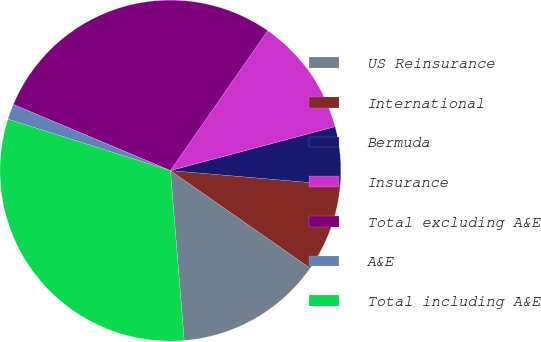Convert chart. <chart><loc_0><loc_0><loc_500><loc_500><pie_chart><fcel>US Reinsurance<fcel>International<fcel>Bermuda<fcel>Insurance<fcel>Total excluding A&E<fcel>A&E<fcel>Total including A&E<nl><fcel>14.01%<fcel>8.34%<fcel>5.51%<fcel>11.18%<fcel>28.33%<fcel>1.46%<fcel>31.16%<nl></chart> 